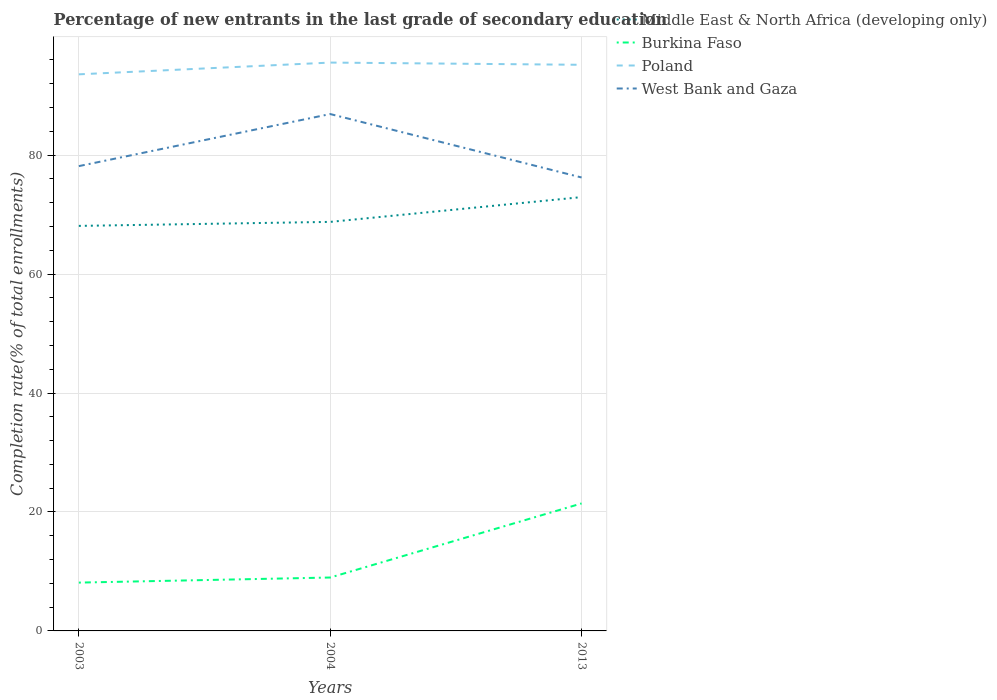Does the line corresponding to West Bank and Gaza intersect with the line corresponding to Middle East & North Africa (developing only)?
Your answer should be compact. No. Is the number of lines equal to the number of legend labels?
Offer a terse response. Yes. Across all years, what is the maximum percentage of new entrants in West Bank and Gaza?
Your answer should be compact. 76.24. What is the total percentage of new entrants in Poland in the graph?
Give a very brief answer. -1.98. What is the difference between the highest and the second highest percentage of new entrants in West Bank and Gaza?
Your answer should be compact. 10.67. Is the percentage of new entrants in West Bank and Gaza strictly greater than the percentage of new entrants in Middle East & North Africa (developing only) over the years?
Keep it short and to the point. No. How many years are there in the graph?
Ensure brevity in your answer.  3. Are the values on the major ticks of Y-axis written in scientific E-notation?
Your answer should be compact. No. Does the graph contain any zero values?
Provide a succinct answer. No. Where does the legend appear in the graph?
Offer a very short reply. Top right. What is the title of the graph?
Your answer should be compact. Percentage of new entrants in the last grade of secondary education. Does "Namibia" appear as one of the legend labels in the graph?
Give a very brief answer. No. What is the label or title of the X-axis?
Your answer should be very brief. Years. What is the label or title of the Y-axis?
Your response must be concise. Completion rate(% of total enrollments). What is the Completion rate(% of total enrollments) of Middle East & North Africa (developing only) in 2003?
Offer a terse response. 68.1. What is the Completion rate(% of total enrollments) in Burkina Faso in 2003?
Your answer should be very brief. 8.12. What is the Completion rate(% of total enrollments) of Poland in 2003?
Offer a very short reply. 93.59. What is the Completion rate(% of total enrollments) in West Bank and Gaza in 2003?
Make the answer very short. 78.15. What is the Completion rate(% of total enrollments) in Middle East & North Africa (developing only) in 2004?
Provide a succinct answer. 68.78. What is the Completion rate(% of total enrollments) of Burkina Faso in 2004?
Offer a very short reply. 8.98. What is the Completion rate(% of total enrollments) of Poland in 2004?
Keep it short and to the point. 95.57. What is the Completion rate(% of total enrollments) in West Bank and Gaza in 2004?
Your answer should be very brief. 86.91. What is the Completion rate(% of total enrollments) in Middle East & North Africa (developing only) in 2013?
Your response must be concise. 72.94. What is the Completion rate(% of total enrollments) of Burkina Faso in 2013?
Keep it short and to the point. 21.44. What is the Completion rate(% of total enrollments) in Poland in 2013?
Your response must be concise. 95.19. What is the Completion rate(% of total enrollments) of West Bank and Gaza in 2013?
Give a very brief answer. 76.24. Across all years, what is the maximum Completion rate(% of total enrollments) of Middle East & North Africa (developing only)?
Offer a terse response. 72.94. Across all years, what is the maximum Completion rate(% of total enrollments) of Burkina Faso?
Give a very brief answer. 21.44. Across all years, what is the maximum Completion rate(% of total enrollments) of Poland?
Offer a very short reply. 95.57. Across all years, what is the maximum Completion rate(% of total enrollments) in West Bank and Gaza?
Your answer should be compact. 86.91. Across all years, what is the minimum Completion rate(% of total enrollments) of Middle East & North Africa (developing only)?
Your response must be concise. 68.1. Across all years, what is the minimum Completion rate(% of total enrollments) in Burkina Faso?
Your response must be concise. 8.12. Across all years, what is the minimum Completion rate(% of total enrollments) in Poland?
Provide a short and direct response. 93.59. Across all years, what is the minimum Completion rate(% of total enrollments) of West Bank and Gaza?
Provide a succinct answer. 76.24. What is the total Completion rate(% of total enrollments) in Middle East & North Africa (developing only) in the graph?
Your answer should be very brief. 209.83. What is the total Completion rate(% of total enrollments) of Burkina Faso in the graph?
Offer a very short reply. 38.54. What is the total Completion rate(% of total enrollments) of Poland in the graph?
Your response must be concise. 284.35. What is the total Completion rate(% of total enrollments) of West Bank and Gaza in the graph?
Ensure brevity in your answer.  241.31. What is the difference between the Completion rate(% of total enrollments) of Middle East & North Africa (developing only) in 2003 and that in 2004?
Make the answer very short. -0.67. What is the difference between the Completion rate(% of total enrollments) of Burkina Faso in 2003 and that in 2004?
Offer a very short reply. -0.85. What is the difference between the Completion rate(% of total enrollments) in Poland in 2003 and that in 2004?
Provide a succinct answer. -1.98. What is the difference between the Completion rate(% of total enrollments) in West Bank and Gaza in 2003 and that in 2004?
Provide a succinct answer. -8.76. What is the difference between the Completion rate(% of total enrollments) of Middle East & North Africa (developing only) in 2003 and that in 2013?
Provide a short and direct response. -4.84. What is the difference between the Completion rate(% of total enrollments) of Burkina Faso in 2003 and that in 2013?
Offer a terse response. -13.31. What is the difference between the Completion rate(% of total enrollments) of Poland in 2003 and that in 2013?
Give a very brief answer. -1.6. What is the difference between the Completion rate(% of total enrollments) in West Bank and Gaza in 2003 and that in 2013?
Your answer should be very brief. 1.91. What is the difference between the Completion rate(% of total enrollments) of Middle East & North Africa (developing only) in 2004 and that in 2013?
Your response must be concise. -4.17. What is the difference between the Completion rate(% of total enrollments) of Burkina Faso in 2004 and that in 2013?
Your response must be concise. -12.46. What is the difference between the Completion rate(% of total enrollments) of Poland in 2004 and that in 2013?
Ensure brevity in your answer.  0.37. What is the difference between the Completion rate(% of total enrollments) of West Bank and Gaza in 2004 and that in 2013?
Provide a short and direct response. 10.67. What is the difference between the Completion rate(% of total enrollments) of Middle East & North Africa (developing only) in 2003 and the Completion rate(% of total enrollments) of Burkina Faso in 2004?
Offer a terse response. 59.13. What is the difference between the Completion rate(% of total enrollments) of Middle East & North Africa (developing only) in 2003 and the Completion rate(% of total enrollments) of Poland in 2004?
Keep it short and to the point. -27.46. What is the difference between the Completion rate(% of total enrollments) in Middle East & North Africa (developing only) in 2003 and the Completion rate(% of total enrollments) in West Bank and Gaza in 2004?
Your response must be concise. -18.81. What is the difference between the Completion rate(% of total enrollments) of Burkina Faso in 2003 and the Completion rate(% of total enrollments) of Poland in 2004?
Ensure brevity in your answer.  -87.44. What is the difference between the Completion rate(% of total enrollments) in Burkina Faso in 2003 and the Completion rate(% of total enrollments) in West Bank and Gaza in 2004?
Give a very brief answer. -78.79. What is the difference between the Completion rate(% of total enrollments) of Poland in 2003 and the Completion rate(% of total enrollments) of West Bank and Gaza in 2004?
Give a very brief answer. 6.68. What is the difference between the Completion rate(% of total enrollments) in Middle East & North Africa (developing only) in 2003 and the Completion rate(% of total enrollments) in Burkina Faso in 2013?
Make the answer very short. 46.67. What is the difference between the Completion rate(% of total enrollments) of Middle East & North Africa (developing only) in 2003 and the Completion rate(% of total enrollments) of Poland in 2013?
Ensure brevity in your answer.  -27.09. What is the difference between the Completion rate(% of total enrollments) of Middle East & North Africa (developing only) in 2003 and the Completion rate(% of total enrollments) of West Bank and Gaza in 2013?
Your answer should be compact. -8.14. What is the difference between the Completion rate(% of total enrollments) of Burkina Faso in 2003 and the Completion rate(% of total enrollments) of Poland in 2013?
Provide a short and direct response. -87.07. What is the difference between the Completion rate(% of total enrollments) in Burkina Faso in 2003 and the Completion rate(% of total enrollments) in West Bank and Gaza in 2013?
Your response must be concise. -68.12. What is the difference between the Completion rate(% of total enrollments) of Poland in 2003 and the Completion rate(% of total enrollments) of West Bank and Gaza in 2013?
Make the answer very short. 17.35. What is the difference between the Completion rate(% of total enrollments) in Middle East & North Africa (developing only) in 2004 and the Completion rate(% of total enrollments) in Burkina Faso in 2013?
Keep it short and to the point. 47.34. What is the difference between the Completion rate(% of total enrollments) of Middle East & North Africa (developing only) in 2004 and the Completion rate(% of total enrollments) of Poland in 2013?
Offer a very short reply. -26.41. What is the difference between the Completion rate(% of total enrollments) of Middle East & North Africa (developing only) in 2004 and the Completion rate(% of total enrollments) of West Bank and Gaza in 2013?
Provide a succinct answer. -7.46. What is the difference between the Completion rate(% of total enrollments) of Burkina Faso in 2004 and the Completion rate(% of total enrollments) of Poland in 2013?
Give a very brief answer. -86.21. What is the difference between the Completion rate(% of total enrollments) in Burkina Faso in 2004 and the Completion rate(% of total enrollments) in West Bank and Gaza in 2013?
Your answer should be very brief. -67.26. What is the difference between the Completion rate(% of total enrollments) of Poland in 2004 and the Completion rate(% of total enrollments) of West Bank and Gaza in 2013?
Provide a short and direct response. 19.32. What is the average Completion rate(% of total enrollments) in Middle East & North Africa (developing only) per year?
Offer a terse response. 69.94. What is the average Completion rate(% of total enrollments) in Burkina Faso per year?
Ensure brevity in your answer.  12.85. What is the average Completion rate(% of total enrollments) in Poland per year?
Ensure brevity in your answer.  94.78. What is the average Completion rate(% of total enrollments) of West Bank and Gaza per year?
Provide a short and direct response. 80.44. In the year 2003, what is the difference between the Completion rate(% of total enrollments) of Middle East & North Africa (developing only) and Completion rate(% of total enrollments) of Burkina Faso?
Your answer should be very brief. 59.98. In the year 2003, what is the difference between the Completion rate(% of total enrollments) in Middle East & North Africa (developing only) and Completion rate(% of total enrollments) in Poland?
Your response must be concise. -25.49. In the year 2003, what is the difference between the Completion rate(% of total enrollments) of Middle East & North Africa (developing only) and Completion rate(% of total enrollments) of West Bank and Gaza?
Your answer should be very brief. -10.05. In the year 2003, what is the difference between the Completion rate(% of total enrollments) in Burkina Faso and Completion rate(% of total enrollments) in Poland?
Your answer should be compact. -85.47. In the year 2003, what is the difference between the Completion rate(% of total enrollments) in Burkina Faso and Completion rate(% of total enrollments) in West Bank and Gaza?
Your answer should be compact. -70.03. In the year 2003, what is the difference between the Completion rate(% of total enrollments) of Poland and Completion rate(% of total enrollments) of West Bank and Gaza?
Ensure brevity in your answer.  15.44. In the year 2004, what is the difference between the Completion rate(% of total enrollments) in Middle East & North Africa (developing only) and Completion rate(% of total enrollments) in Burkina Faso?
Provide a succinct answer. 59.8. In the year 2004, what is the difference between the Completion rate(% of total enrollments) of Middle East & North Africa (developing only) and Completion rate(% of total enrollments) of Poland?
Keep it short and to the point. -26.79. In the year 2004, what is the difference between the Completion rate(% of total enrollments) of Middle East & North Africa (developing only) and Completion rate(% of total enrollments) of West Bank and Gaza?
Provide a succinct answer. -18.13. In the year 2004, what is the difference between the Completion rate(% of total enrollments) of Burkina Faso and Completion rate(% of total enrollments) of Poland?
Give a very brief answer. -86.59. In the year 2004, what is the difference between the Completion rate(% of total enrollments) in Burkina Faso and Completion rate(% of total enrollments) in West Bank and Gaza?
Your answer should be very brief. -77.93. In the year 2004, what is the difference between the Completion rate(% of total enrollments) of Poland and Completion rate(% of total enrollments) of West Bank and Gaza?
Make the answer very short. 8.65. In the year 2013, what is the difference between the Completion rate(% of total enrollments) in Middle East & North Africa (developing only) and Completion rate(% of total enrollments) in Burkina Faso?
Your answer should be compact. 51.51. In the year 2013, what is the difference between the Completion rate(% of total enrollments) in Middle East & North Africa (developing only) and Completion rate(% of total enrollments) in Poland?
Ensure brevity in your answer.  -22.25. In the year 2013, what is the difference between the Completion rate(% of total enrollments) of Middle East & North Africa (developing only) and Completion rate(% of total enrollments) of West Bank and Gaza?
Keep it short and to the point. -3.3. In the year 2013, what is the difference between the Completion rate(% of total enrollments) in Burkina Faso and Completion rate(% of total enrollments) in Poland?
Offer a terse response. -73.75. In the year 2013, what is the difference between the Completion rate(% of total enrollments) in Burkina Faso and Completion rate(% of total enrollments) in West Bank and Gaza?
Your answer should be very brief. -54.81. In the year 2013, what is the difference between the Completion rate(% of total enrollments) in Poland and Completion rate(% of total enrollments) in West Bank and Gaza?
Your answer should be compact. 18.95. What is the ratio of the Completion rate(% of total enrollments) in Middle East & North Africa (developing only) in 2003 to that in 2004?
Keep it short and to the point. 0.99. What is the ratio of the Completion rate(% of total enrollments) in Burkina Faso in 2003 to that in 2004?
Your answer should be compact. 0.9. What is the ratio of the Completion rate(% of total enrollments) of Poland in 2003 to that in 2004?
Your response must be concise. 0.98. What is the ratio of the Completion rate(% of total enrollments) of West Bank and Gaza in 2003 to that in 2004?
Your response must be concise. 0.9. What is the ratio of the Completion rate(% of total enrollments) of Middle East & North Africa (developing only) in 2003 to that in 2013?
Your answer should be very brief. 0.93. What is the ratio of the Completion rate(% of total enrollments) in Burkina Faso in 2003 to that in 2013?
Ensure brevity in your answer.  0.38. What is the ratio of the Completion rate(% of total enrollments) in Poland in 2003 to that in 2013?
Your answer should be very brief. 0.98. What is the ratio of the Completion rate(% of total enrollments) of West Bank and Gaza in 2003 to that in 2013?
Ensure brevity in your answer.  1.03. What is the ratio of the Completion rate(% of total enrollments) in Middle East & North Africa (developing only) in 2004 to that in 2013?
Ensure brevity in your answer.  0.94. What is the ratio of the Completion rate(% of total enrollments) of Burkina Faso in 2004 to that in 2013?
Your response must be concise. 0.42. What is the ratio of the Completion rate(% of total enrollments) in West Bank and Gaza in 2004 to that in 2013?
Provide a succinct answer. 1.14. What is the difference between the highest and the second highest Completion rate(% of total enrollments) in Middle East & North Africa (developing only)?
Offer a very short reply. 4.17. What is the difference between the highest and the second highest Completion rate(% of total enrollments) of Burkina Faso?
Give a very brief answer. 12.46. What is the difference between the highest and the second highest Completion rate(% of total enrollments) in Poland?
Your response must be concise. 0.37. What is the difference between the highest and the second highest Completion rate(% of total enrollments) in West Bank and Gaza?
Provide a short and direct response. 8.76. What is the difference between the highest and the lowest Completion rate(% of total enrollments) in Middle East & North Africa (developing only)?
Your answer should be compact. 4.84. What is the difference between the highest and the lowest Completion rate(% of total enrollments) in Burkina Faso?
Give a very brief answer. 13.31. What is the difference between the highest and the lowest Completion rate(% of total enrollments) of Poland?
Your response must be concise. 1.98. What is the difference between the highest and the lowest Completion rate(% of total enrollments) in West Bank and Gaza?
Give a very brief answer. 10.67. 